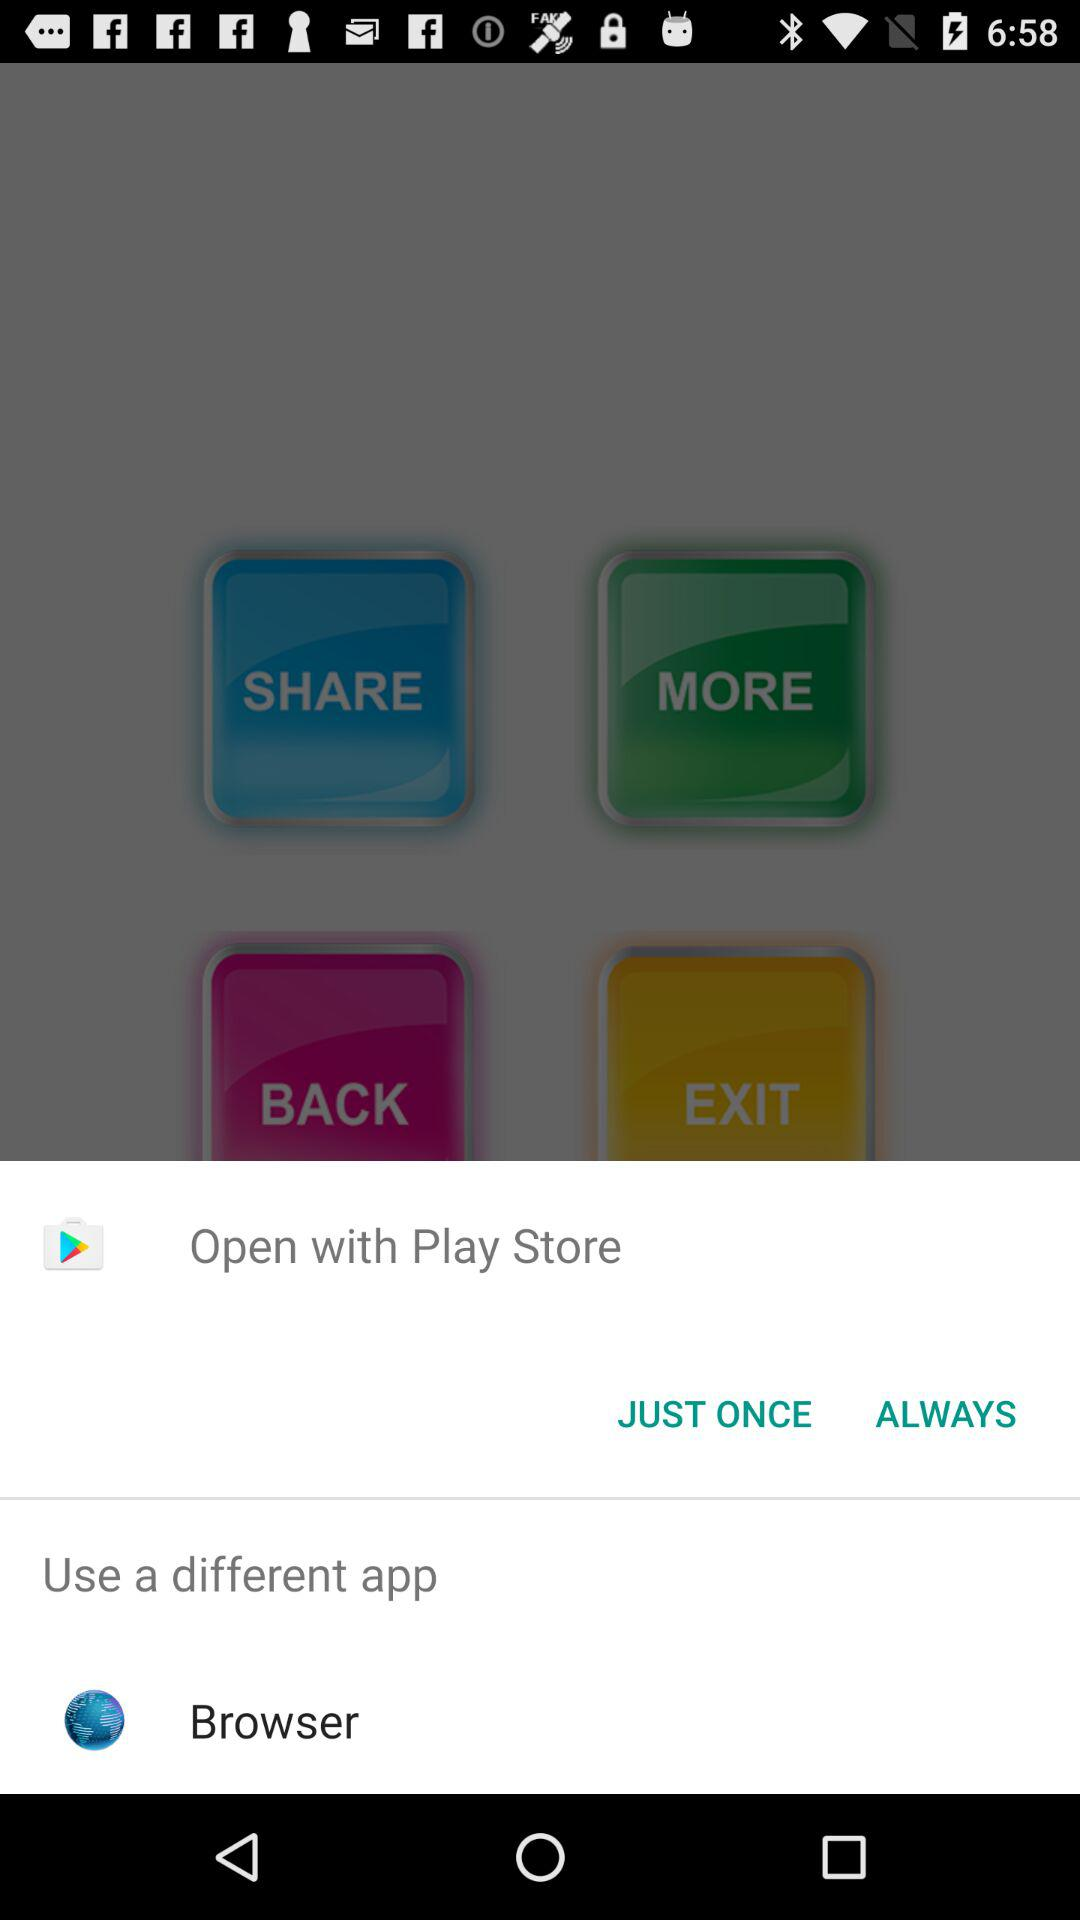What application can I use to open the content? You can use "Play Store" to open the content. 